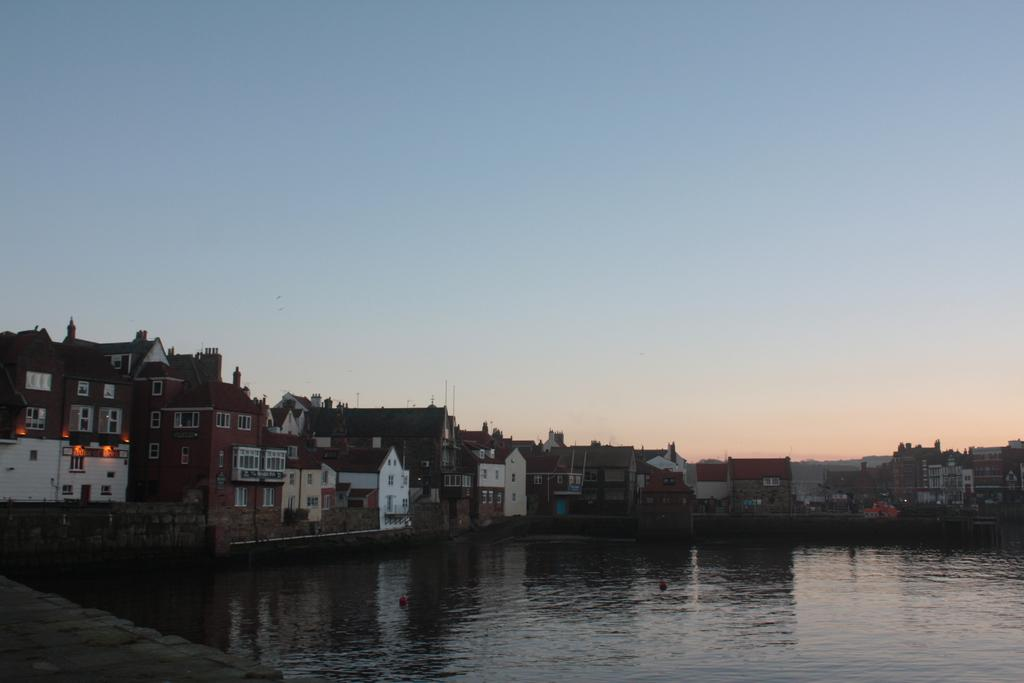What type of structures are visible in the image? There are many buildings in the image. What natural feature can be seen in the image? There is a pond in the image. What is visible at the top of the image? The sky is visible at the top of the image. How many apples are floating in the pond in the image? There are no apples present in the image; it features many buildings and a pond, but there are no apples visible in the image. 